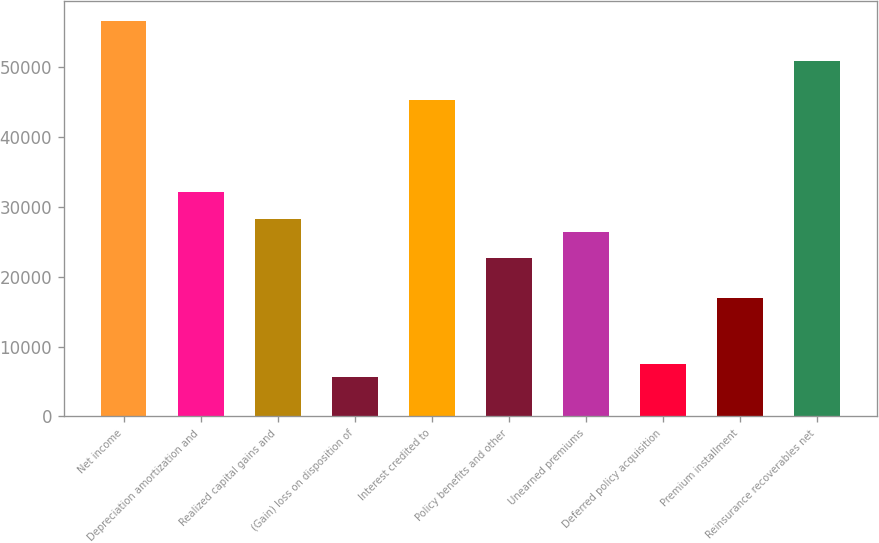Convert chart to OTSL. <chart><loc_0><loc_0><loc_500><loc_500><bar_chart><fcel>Net income<fcel>Depreciation amortization and<fcel>Realized capital gains and<fcel>(Gain) loss on disposition of<fcel>Interest credited to<fcel>Policy benefits and other<fcel>Unearned premiums<fcel>Deferred policy acquisition<fcel>Premium installment<fcel>Reinsurance recoverables net<nl><fcel>56596<fcel>32075.4<fcel>28303<fcel>5668.6<fcel>45278.8<fcel>22644.4<fcel>26416.8<fcel>7554.8<fcel>16985.8<fcel>50937.4<nl></chart> 